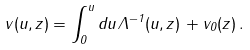<formula> <loc_0><loc_0><loc_500><loc_500>v ( u , z ) = \int ^ { u } _ { 0 } d u \, \Lambda ^ { - 1 } ( u , z ) \, + v _ { 0 } ( z ) \, .</formula> 